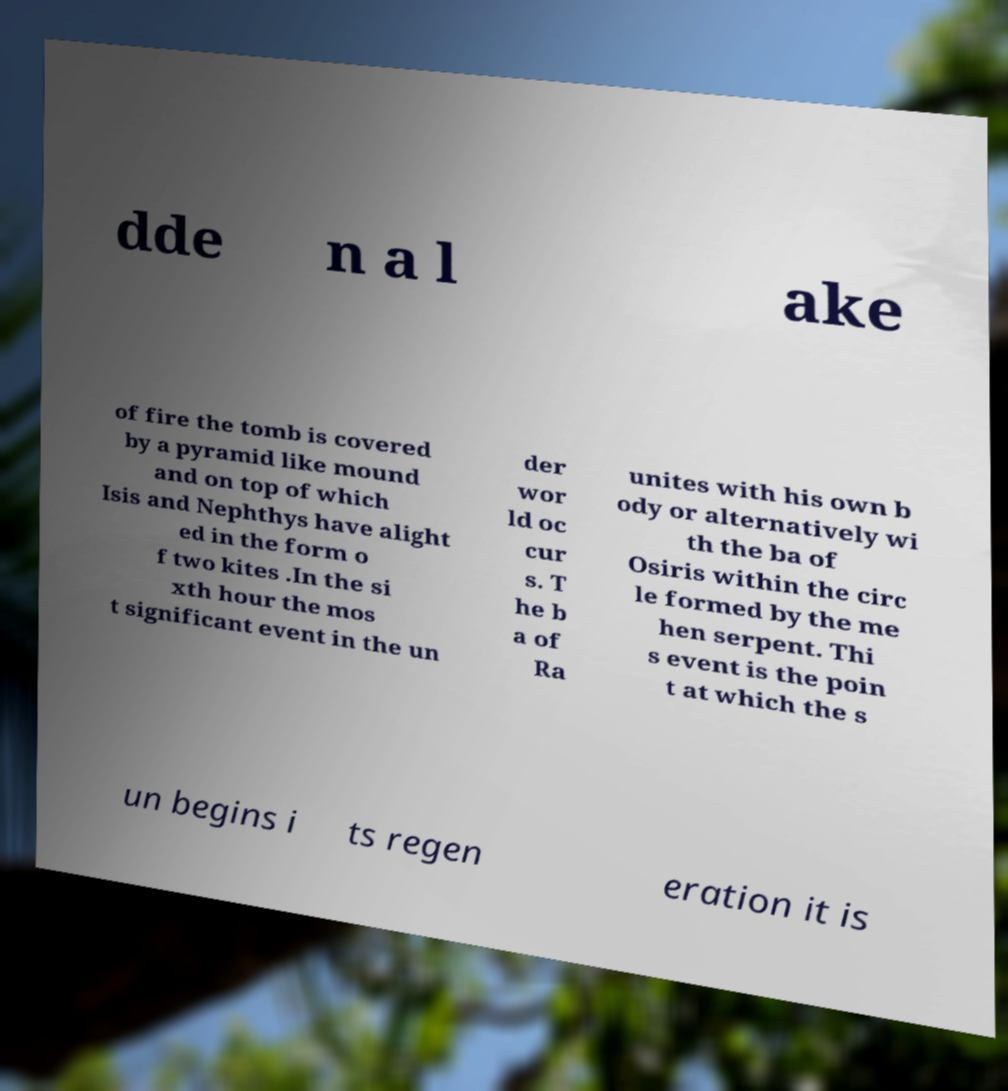What messages or text are displayed in this image? I need them in a readable, typed format. dde n a l ake of fire the tomb is covered by a pyramid like mound and on top of which Isis and Nephthys have alight ed in the form o f two kites .In the si xth hour the mos t significant event in the un der wor ld oc cur s. T he b a of Ra unites with his own b ody or alternatively wi th the ba of Osiris within the circ le formed by the me hen serpent. Thi s event is the poin t at which the s un begins i ts regen eration it is 